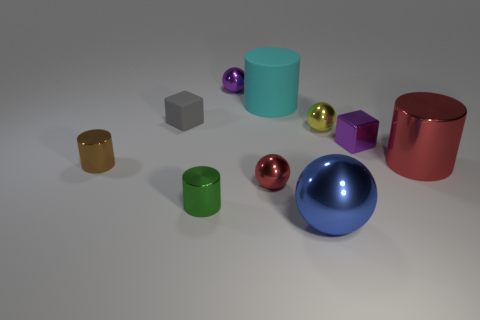What is the color of the large cylinder that is the same material as the small purple cube?
Your answer should be compact. Red. What number of metallic things are either large green things or blue things?
Provide a short and direct response. 1. Is the material of the cyan object the same as the big red cylinder?
Your answer should be compact. No. The big metal thing that is to the right of the small purple shiny cube has what shape?
Your response must be concise. Cylinder. Are there any metal objects that are on the left side of the large object that is in front of the green metallic cylinder?
Offer a very short reply. Yes. Are there any cyan matte cylinders of the same size as the purple block?
Give a very brief answer. No. There is a big cylinder that is in front of the small matte thing; is its color the same as the large metal sphere?
Offer a very short reply. No. What size is the blue ball?
Give a very brief answer. Large. There is a purple metallic object right of the small metallic sphere that is in front of the tiny brown thing; what size is it?
Ensure brevity in your answer.  Small. What number of large rubber cylinders have the same color as the large sphere?
Offer a very short reply. 0. 